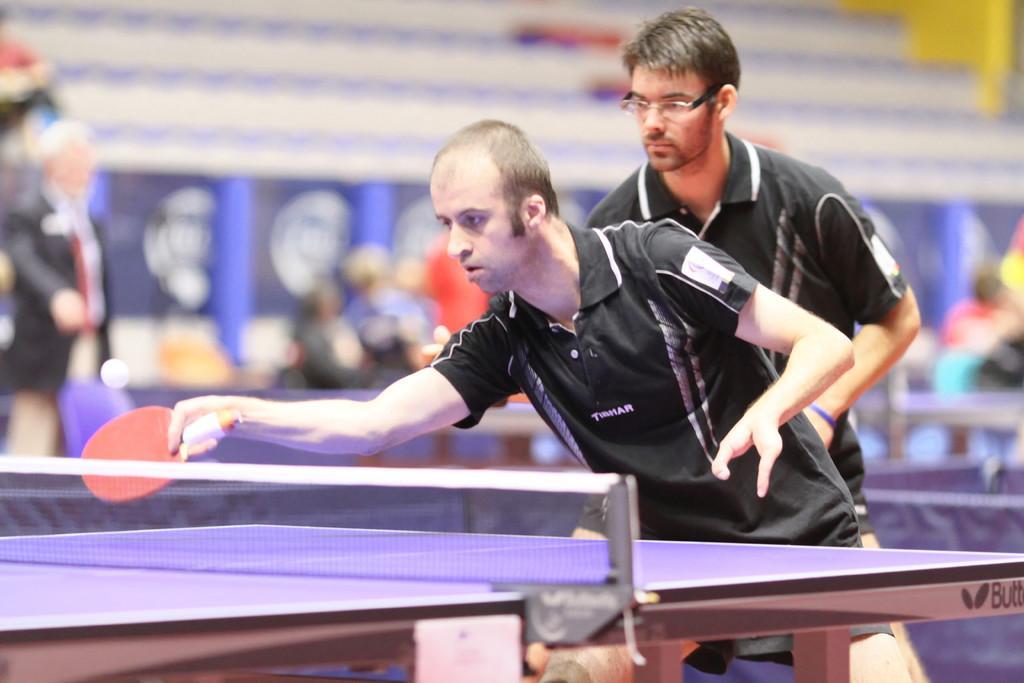Can you describe this image briefly? In this image we can see two persons wearing black color dress and a person holding tennis racket in his hands which is of red color standing near the table tennis court, at the middle of the image there is net and at the background of the image there are some persons and these two persons are playing table tennis. 